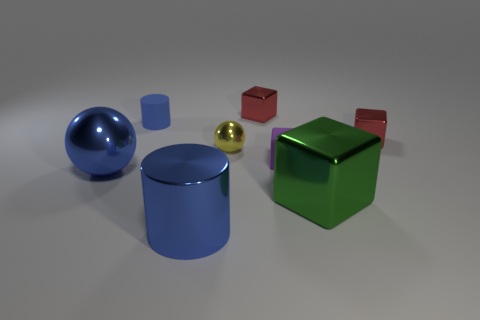Is there a red thing that has the same size as the shiny cylinder?
Offer a very short reply. No. Is the color of the sphere that is behind the big metallic ball the same as the big shiny sphere?
Your response must be concise. No. What number of purple things are small objects or large metal blocks?
Make the answer very short. 1. How many small metal balls have the same color as the big shiny cylinder?
Give a very brief answer. 0. Is the material of the large blue cylinder the same as the small cylinder?
Keep it short and to the point. No. How many big green cubes are on the left side of the metal cube in front of the small purple rubber object?
Offer a very short reply. 0. Does the blue shiny cylinder have the same size as the yellow sphere?
Provide a succinct answer. No. How many small blue objects have the same material as the tiny purple block?
Keep it short and to the point. 1. The shiny object that is the same shape as the tiny blue matte object is what size?
Make the answer very short. Large. Is the shape of the tiny red metallic thing to the left of the purple cube the same as  the yellow thing?
Offer a very short reply. No. 